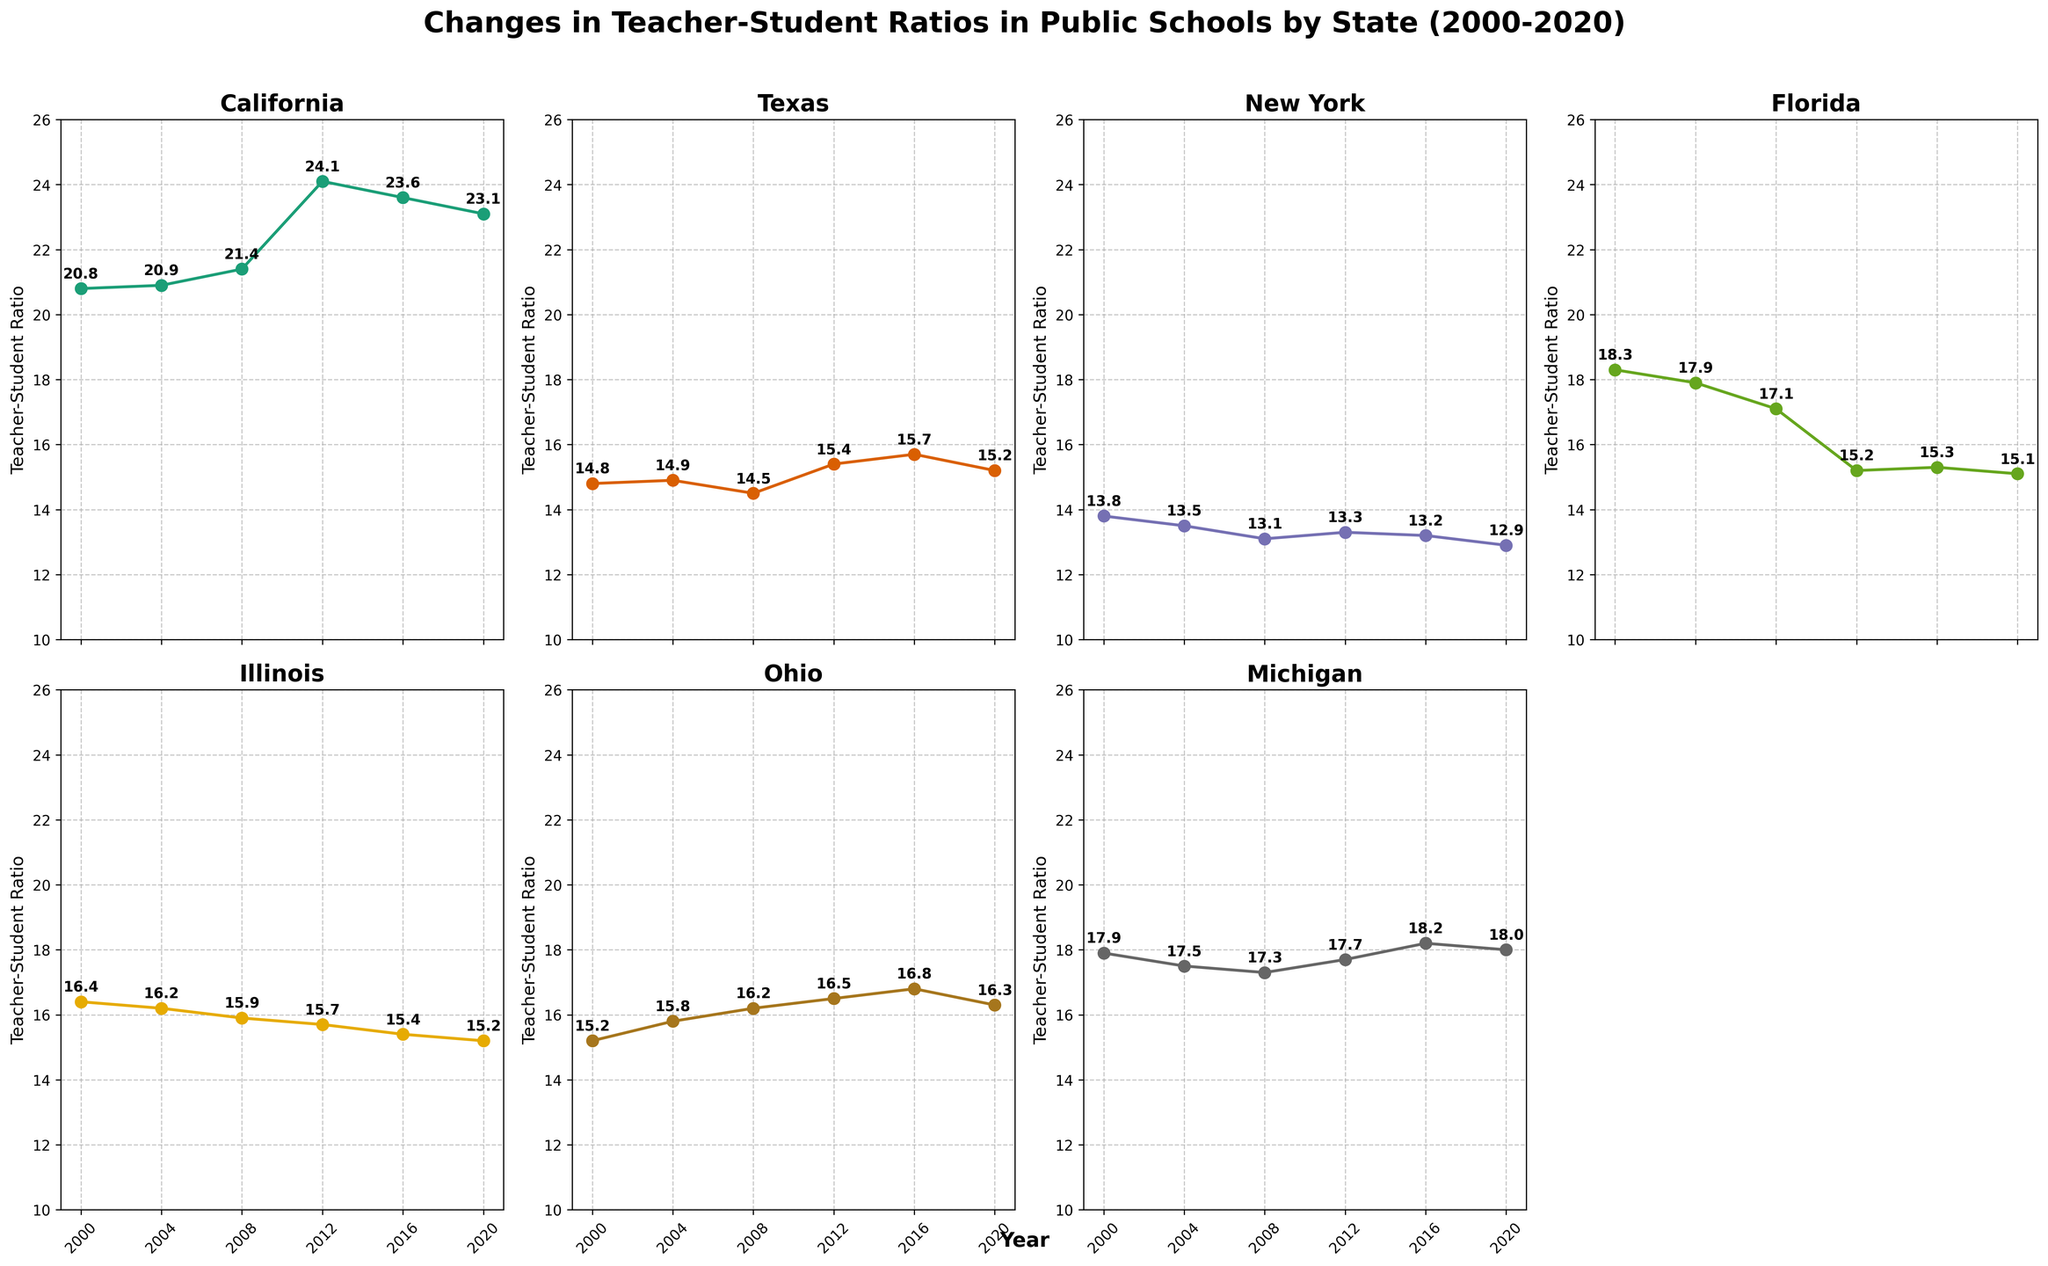What is the title of the figure? The title of the figure is displayed at the top and reads "Changes in Teacher-Student Ratios in Public Schools by State (2000-2020)."
Answer: Changes in Teacher-Student Ratios in Public Schools by State (2000-2020) Which state had the highest teacher-student ratio in 2020? By comparing the last data point in all subplots for the year 2020, California has the highest teacher-student ratio with a value of 23.1.
Answer: California How did the teacher-student ratio in New York change from 2000 to 2020? In New York, the teacher-student ratio decreased from 13.8 in 2000 to 12.9 in 2020, which can be observed by looking at the start and end values in the New York subplot.
Answer: Decreased Which state experienced the most significant increase in teacher-student ratio from 2000 to its highest point within these 20 years? California's teacher-student ratio increased the most, from 20.8 in 2000 to its peak of 24.1 in 2012. This increase of 3.3 is the largest among all states when comparing all years.
Answer: California In what year did Ohio have its highest teacher-student ratio, and what was the value? In the Ohio subplot, the highest teacher-student ratio is 16.8, which occurred in 2016.
Answer: 2016, 16.8 Which two states had approximately equal teacher-student ratios around 2012? Comparing the subplots for 2012, both Illinois and New York had similar teacher-student ratios, with values of 15.7 and 13.3 respectively.
Answer: Illinois, New York How does the teacher-student ratio trend in Florida compare to California from 2000 to 2020? From 2000 to 2020, the teacher-student ratio in Florida consistently decreased, while in California, it increased initially until 2012 and then decreased. Specifically, in Florida, it went from 18.3 to 15.1, while in California, it peaked at 24.1 in 2012 and decreased to 23.1 by 2020.
Answer: Florida decreased, California increased then decreased What was the teacher-student ratio for Michigan in 2016, and how does it compare to 2020? In 2016, Michigan's teacher-student ratio was 18.2, which then slightly decreased to 18.0 in 2020.
Answer: 18.2 in 2016, 18.0 in 2020 Which state had the most stable (least change) teacher-student ratio over the period from 2000 to 2020? New York had the most stable teacher-student ratio; it started at 13.8 in 2000 and only decreased slightly to 12.9 in 2020, showing the least variance.
Answer: New York 